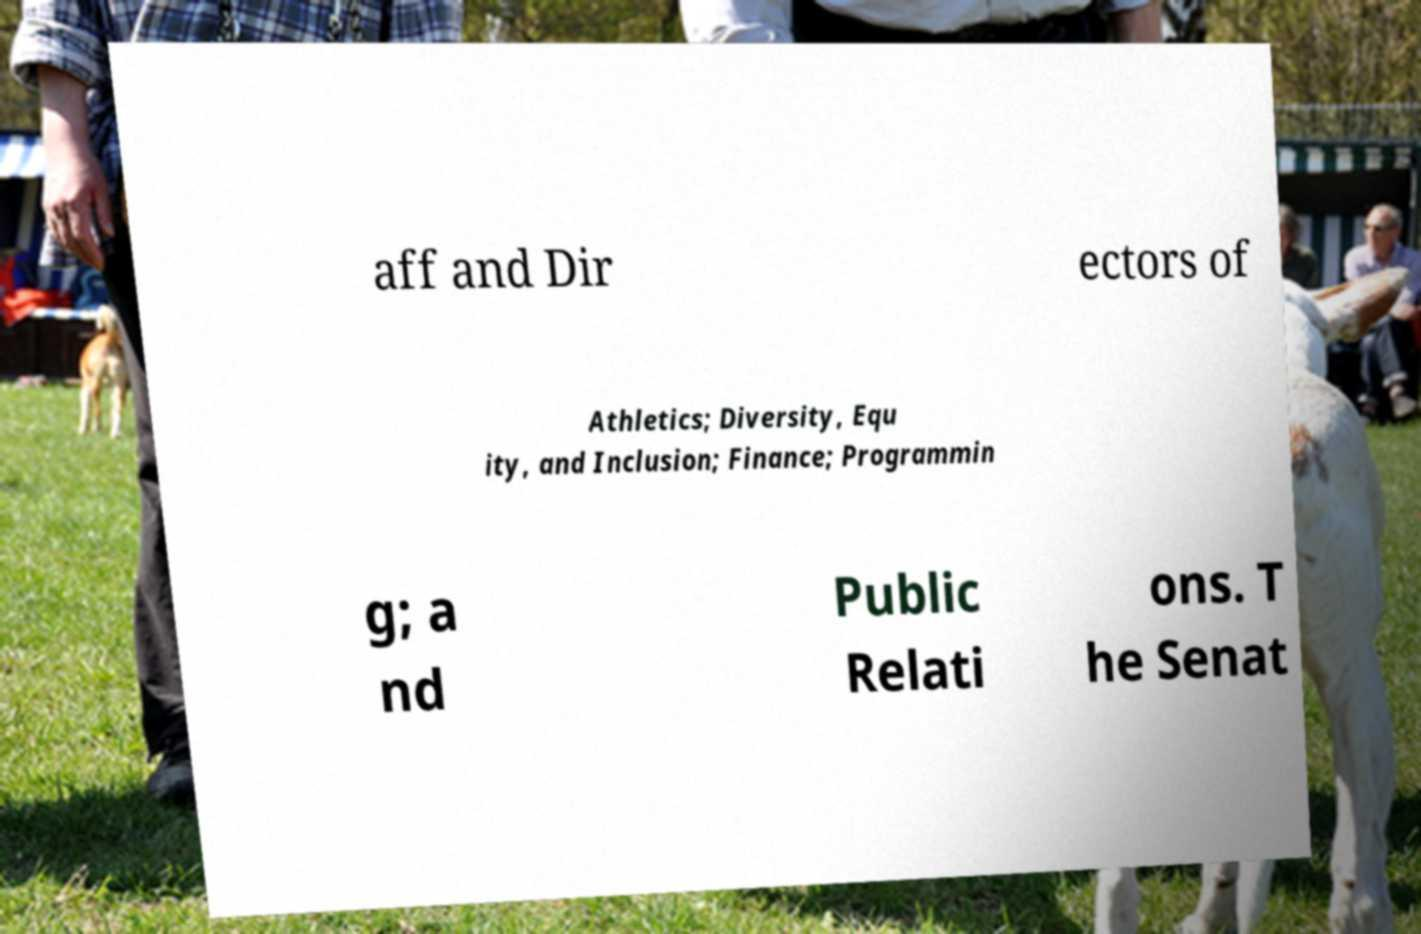Could you assist in decoding the text presented in this image and type it out clearly? aff and Dir ectors of Athletics; Diversity, Equ ity, and Inclusion; Finance; Programmin g; a nd Public Relati ons. T he Senat 